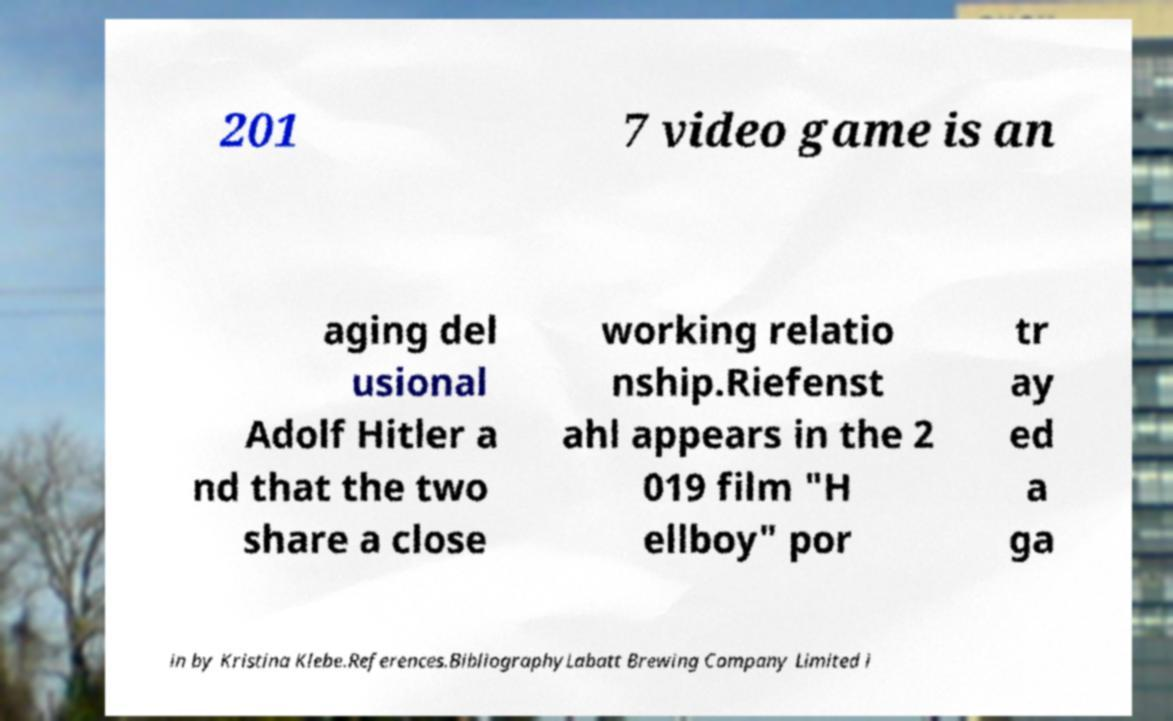I need the written content from this picture converted into text. Can you do that? 201 7 video game is an aging del usional Adolf Hitler a nd that the two share a close working relatio nship.Riefenst ahl appears in the 2 019 film "H ellboy" por tr ay ed a ga in by Kristina Klebe.References.BibliographyLabatt Brewing Company Limited i 